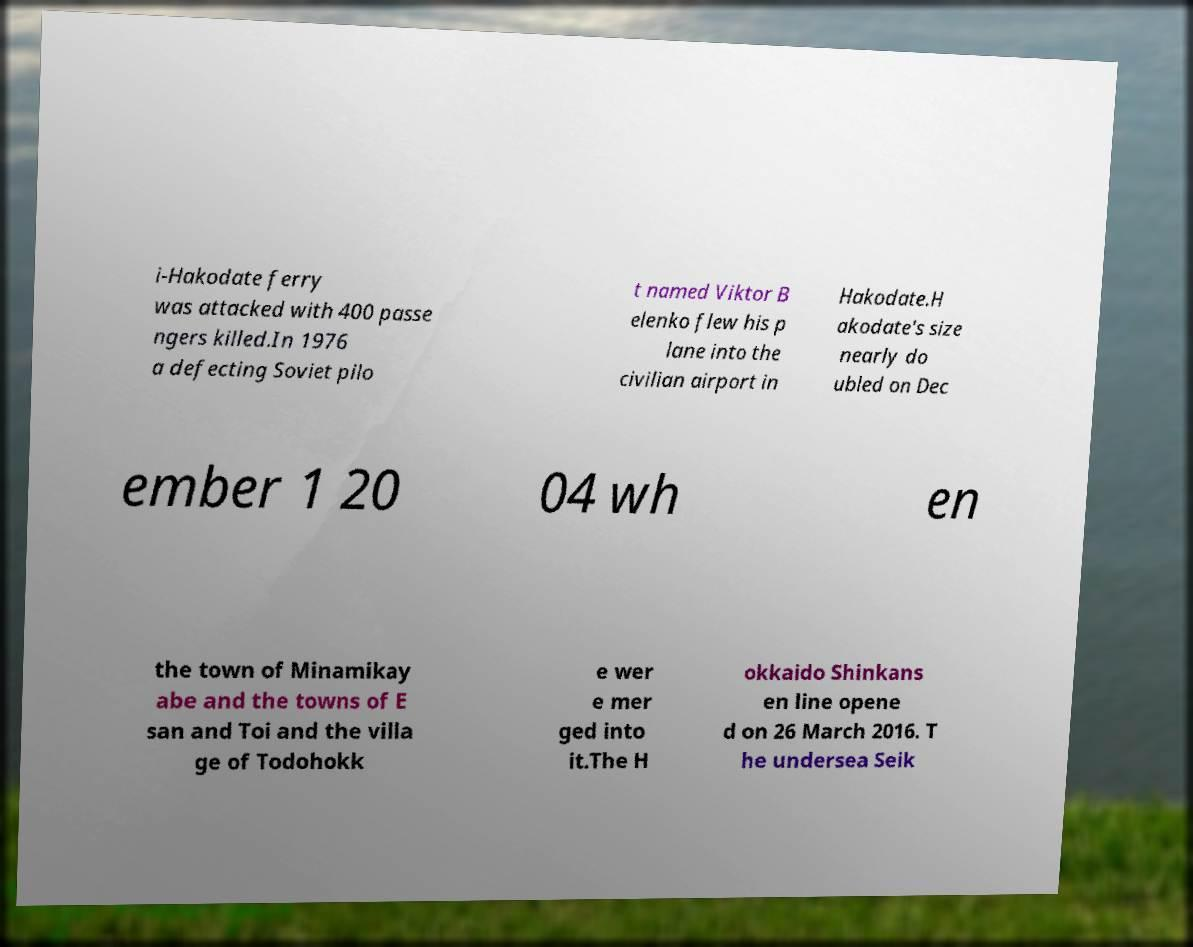There's text embedded in this image that I need extracted. Can you transcribe it verbatim? i-Hakodate ferry was attacked with 400 passe ngers killed.In 1976 a defecting Soviet pilo t named Viktor B elenko flew his p lane into the civilian airport in Hakodate.H akodate's size nearly do ubled on Dec ember 1 20 04 wh en the town of Minamikay abe and the towns of E san and Toi and the villa ge of Todohokk e wer e mer ged into it.The H okkaido Shinkans en line opene d on 26 March 2016. T he undersea Seik 